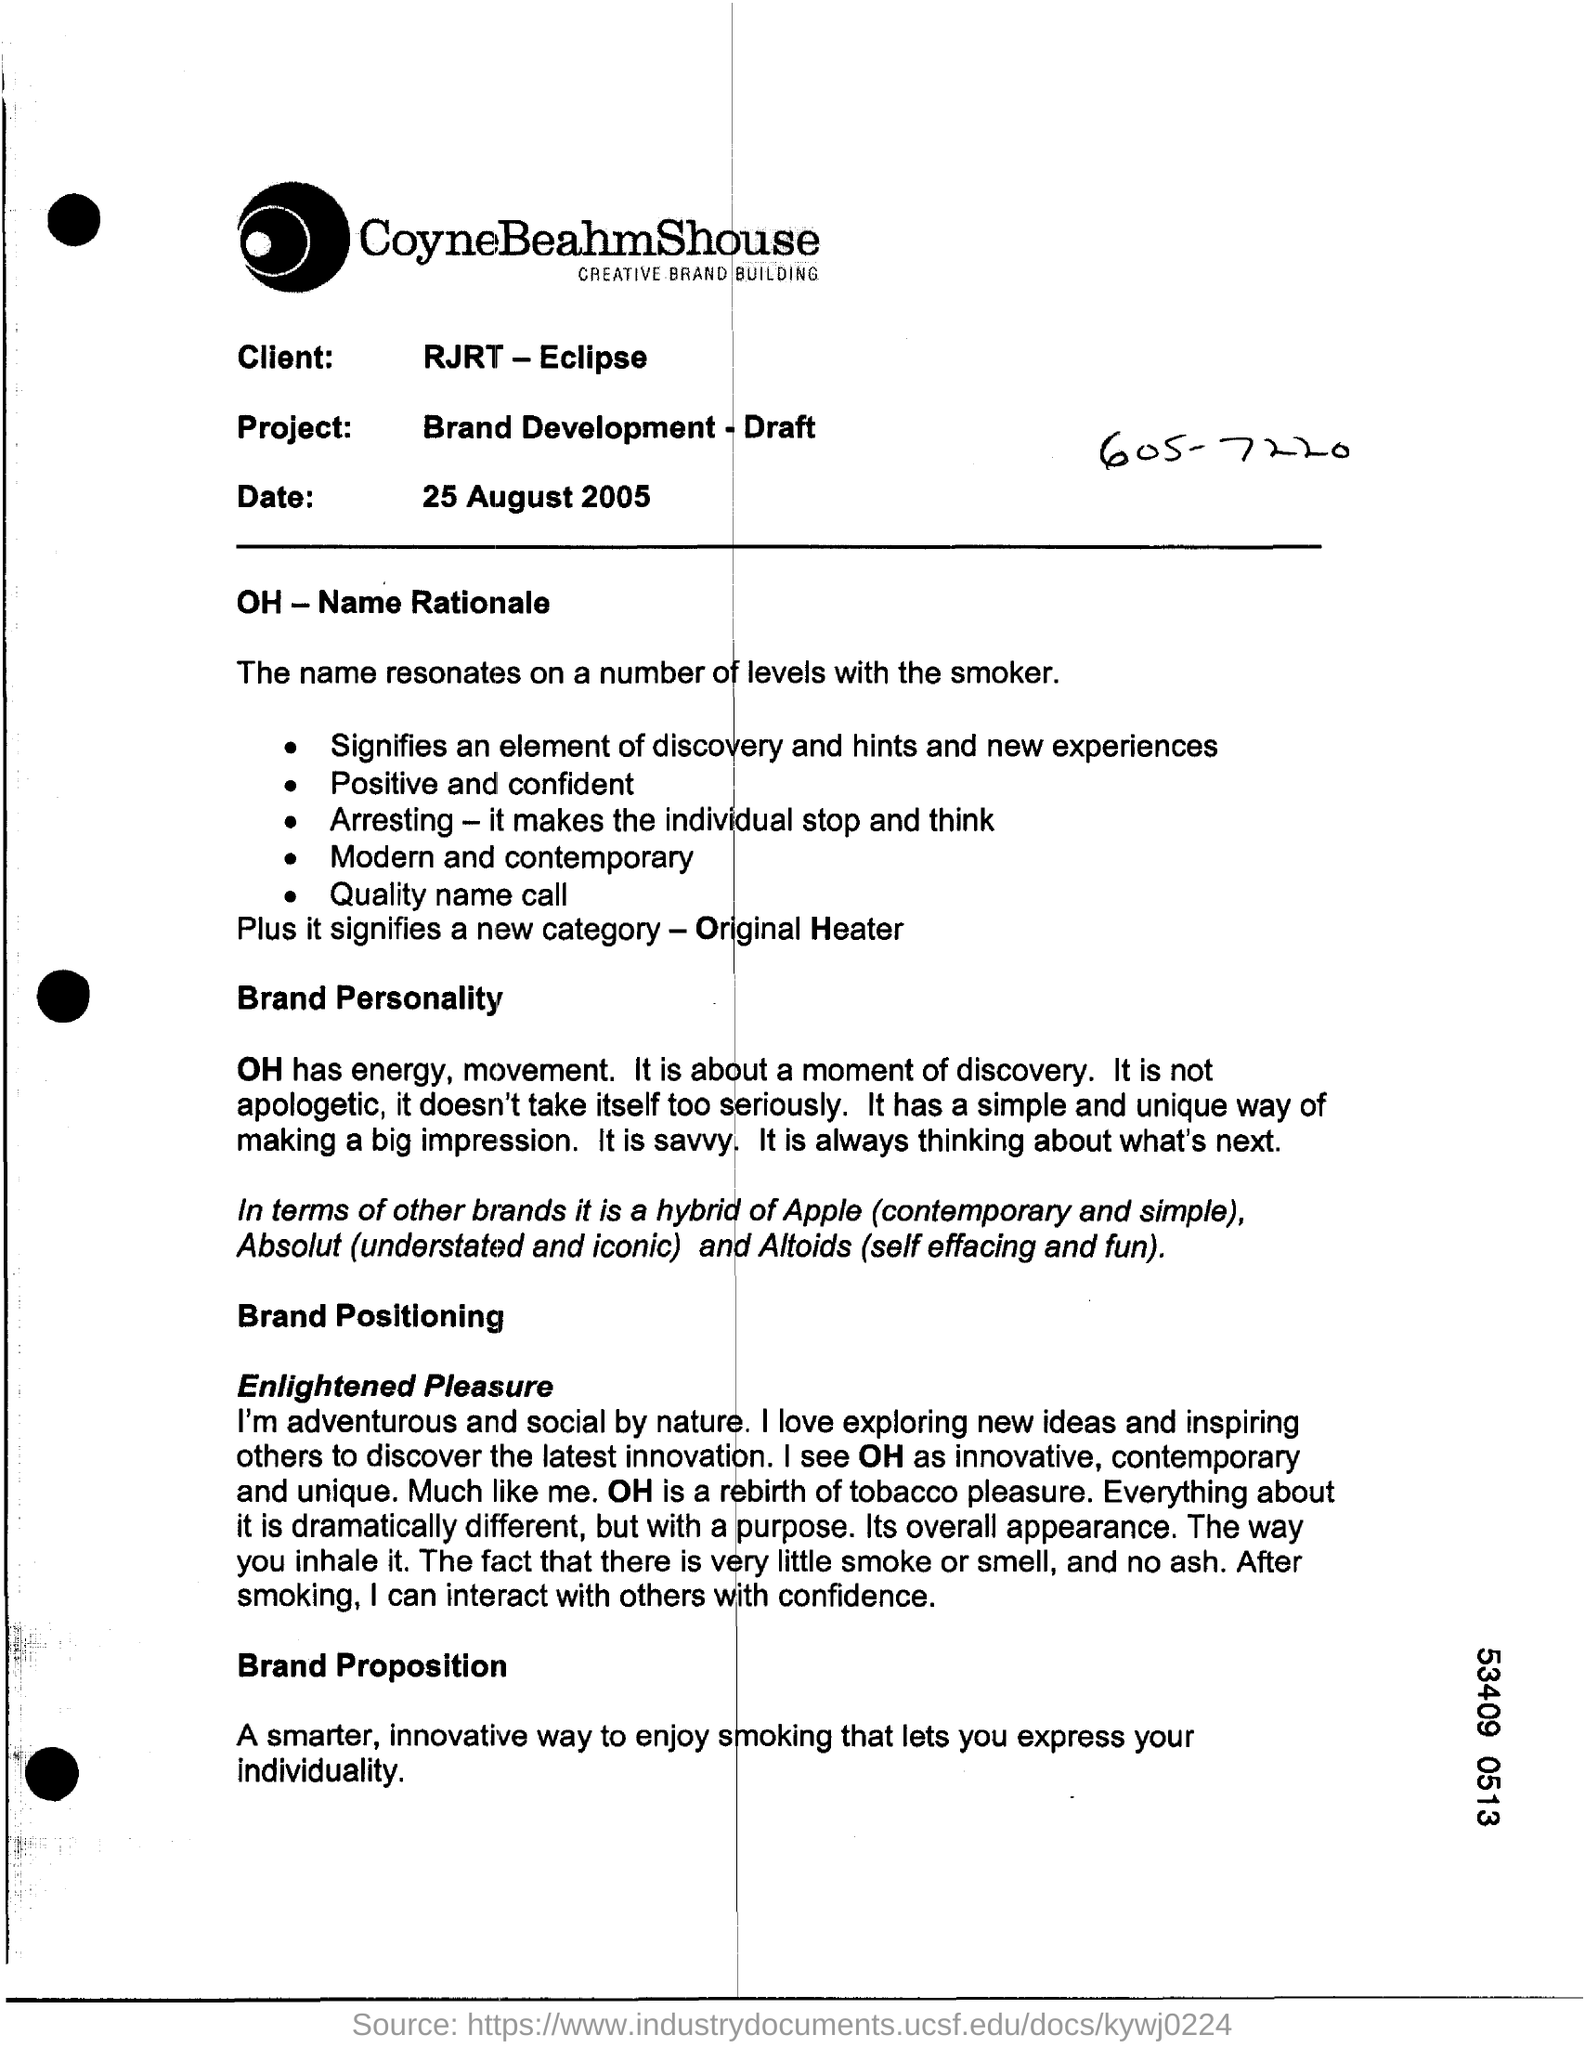Mention a couple of crucial points in this snapshot. The project name is "Brand development - draft. The client's name is RJRT - Eclipse. 